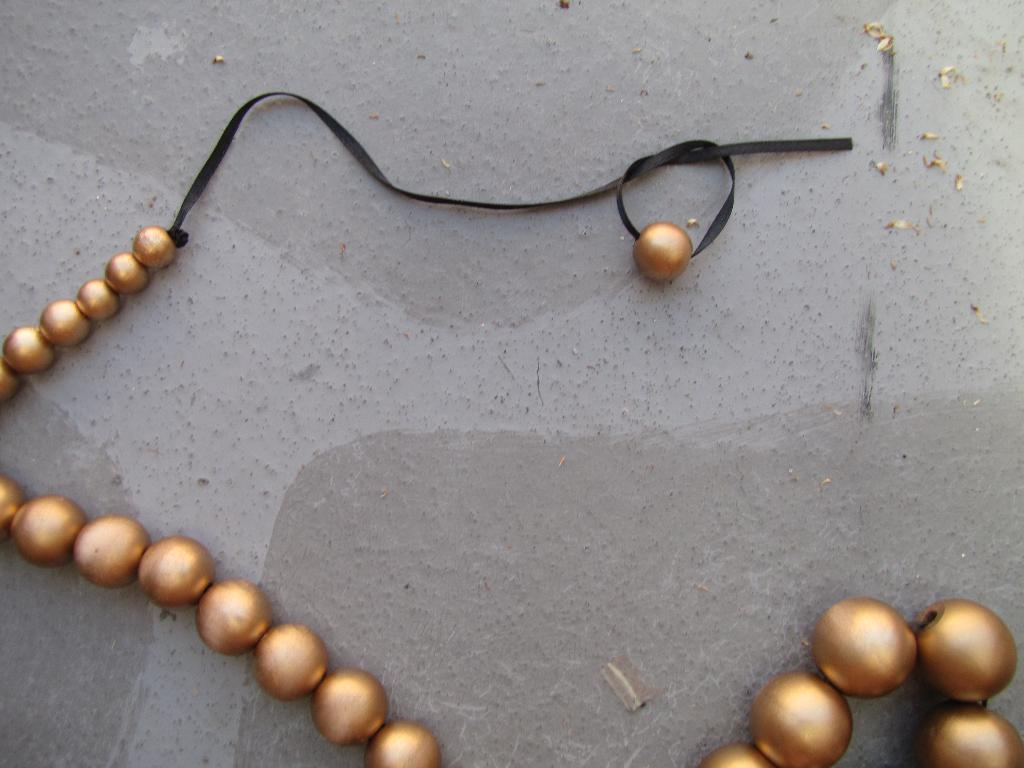What is on the floor in the image? There is a chain with circular beads on the floor. Can you describe the chain in the image? The chain has circular beads. What type of cabbage is growing in the image? There is no cabbage present in the image; it features a chain with circular beads on the floor. What direction is the zephyr blowing in the image? There is no mention of a zephyr or any wind in the image; it only shows a chain with circular beads on the floor. 